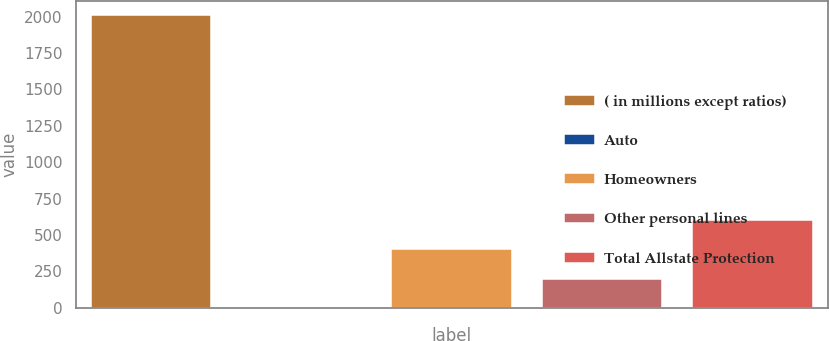<chart> <loc_0><loc_0><loc_500><loc_500><bar_chart><fcel>( in millions except ratios)<fcel>Auto<fcel>Homeowners<fcel>Other personal lines<fcel>Total Allstate Protection<nl><fcel>2008<fcel>0.1<fcel>401.68<fcel>200.89<fcel>602.47<nl></chart> 